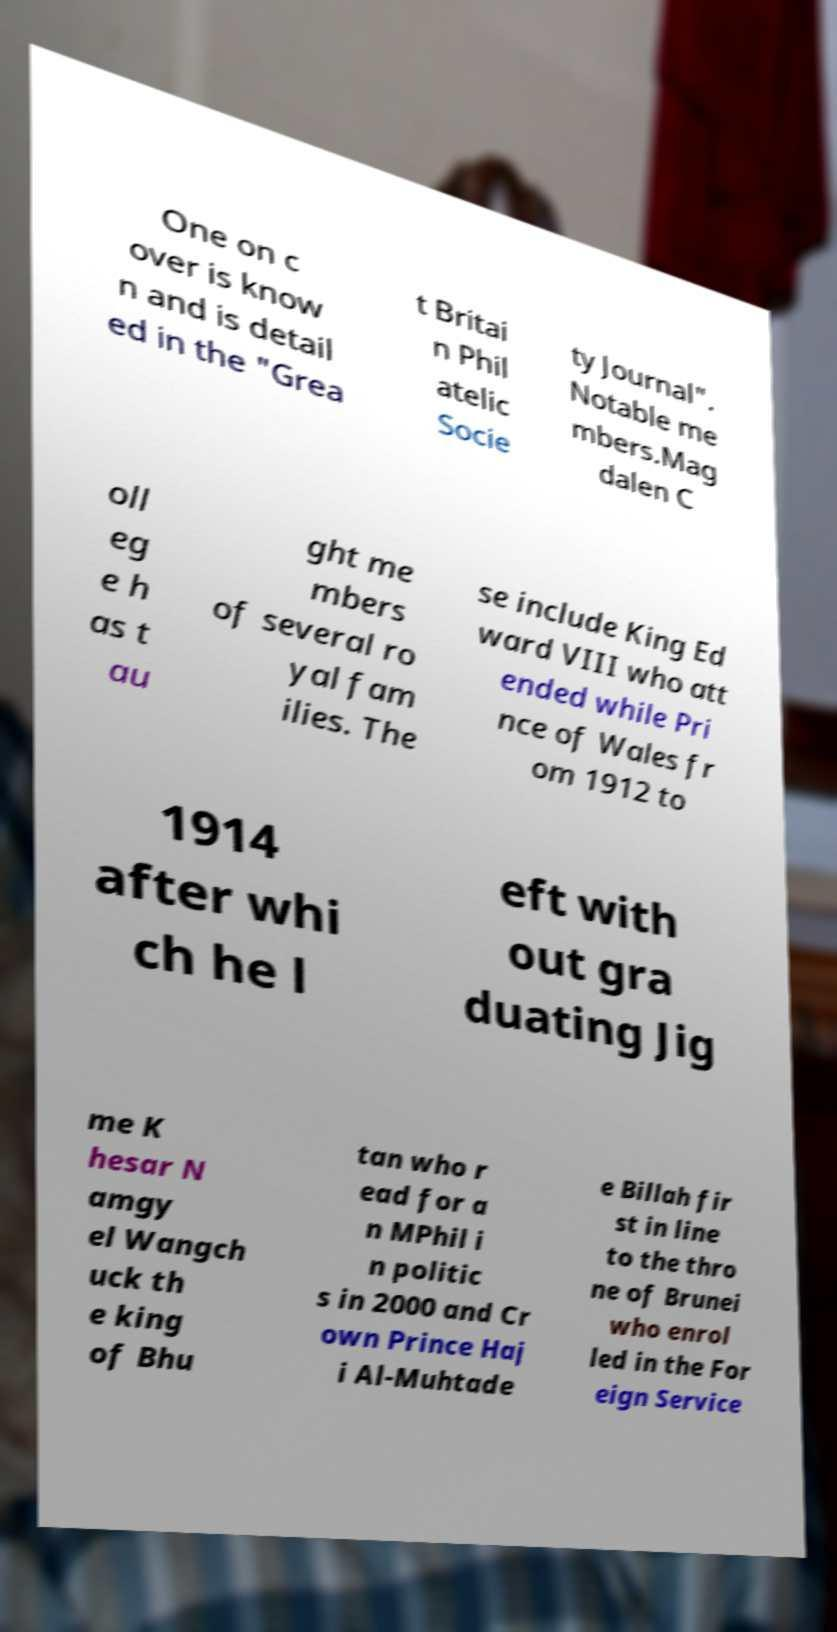Can you accurately transcribe the text from the provided image for me? One on c over is know n and is detail ed in the "Grea t Britai n Phil atelic Socie ty Journal". Notable me mbers.Mag dalen C oll eg e h as t au ght me mbers of several ro yal fam ilies. The se include King Ed ward VIII who att ended while Pri nce of Wales fr om 1912 to 1914 after whi ch he l eft with out gra duating Jig me K hesar N amgy el Wangch uck th e king of Bhu tan who r ead for a n MPhil i n politic s in 2000 and Cr own Prince Haj i Al-Muhtade e Billah fir st in line to the thro ne of Brunei who enrol led in the For eign Service 